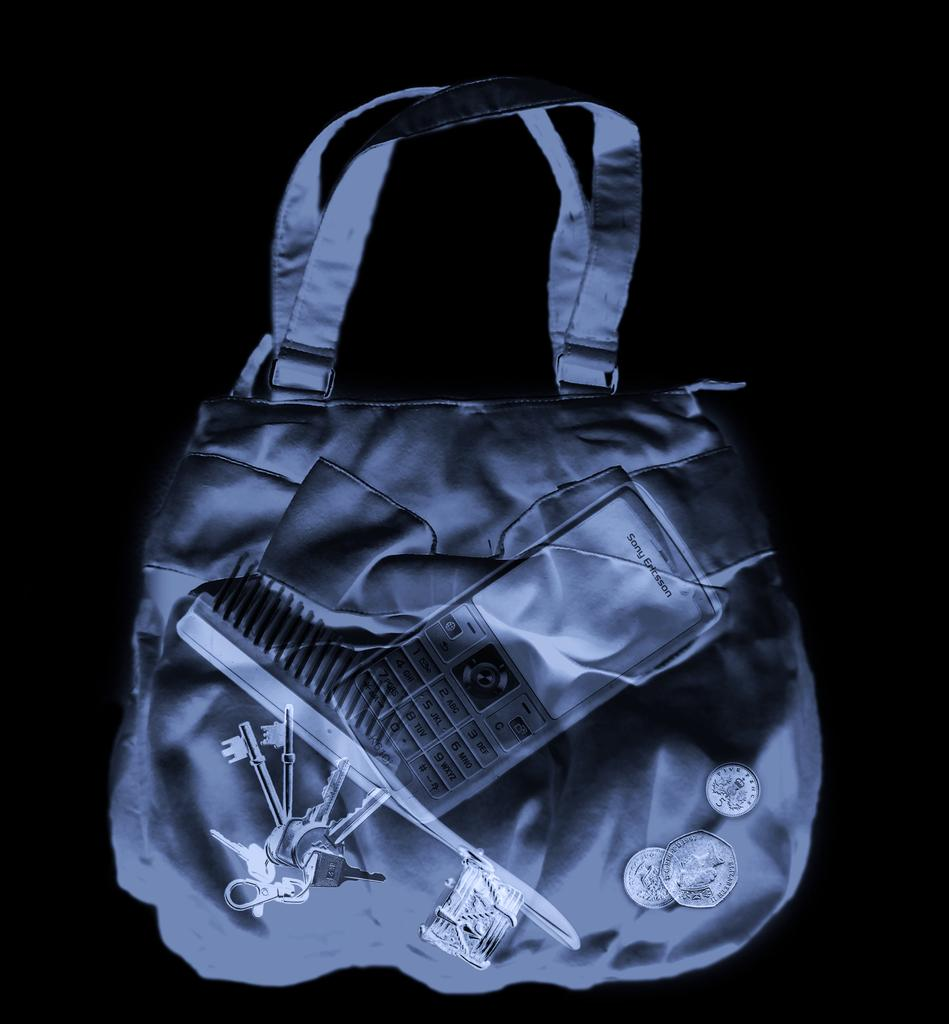What object is visible in the image? There is a handbag in the image. What items can be found inside the handbag? A mobile phone, a comb, keys, and coins are present inside the handbag. How far is the distance the comb has traveled in the image? The image does not provide information about the comb's travel distance, as it is inside the handbag and not in motion. 